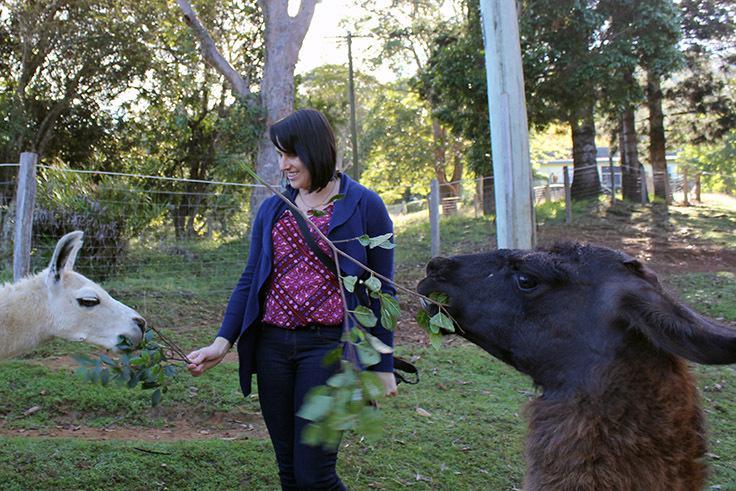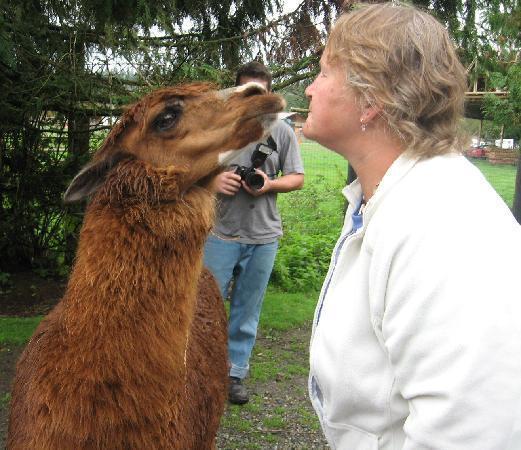The first image is the image on the left, the second image is the image on the right. Given the left and right images, does the statement "In one image, multiple children are standing in front of at least one llama, with their hands outstretched to feed it." hold true? Answer yes or no. No. The first image is the image on the left, the second image is the image on the right. For the images shown, is this caption "There are children feeding a llama." true? Answer yes or no. No. 